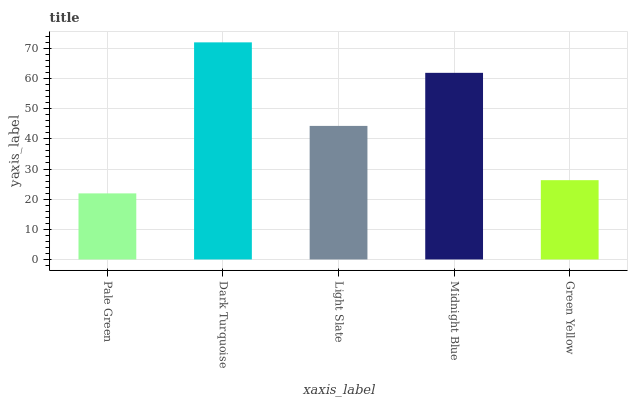Is Pale Green the minimum?
Answer yes or no. Yes. Is Dark Turquoise the maximum?
Answer yes or no. Yes. Is Light Slate the minimum?
Answer yes or no. No. Is Light Slate the maximum?
Answer yes or no. No. Is Dark Turquoise greater than Light Slate?
Answer yes or no. Yes. Is Light Slate less than Dark Turquoise?
Answer yes or no. Yes. Is Light Slate greater than Dark Turquoise?
Answer yes or no. No. Is Dark Turquoise less than Light Slate?
Answer yes or no. No. Is Light Slate the high median?
Answer yes or no. Yes. Is Light Slate the low median?
Answer yes or no. Yes. Is Dark Turquoise the high median?
Answer yes or no. No. Is Dark Turquoise the low median?
Answer yes or no. No. 